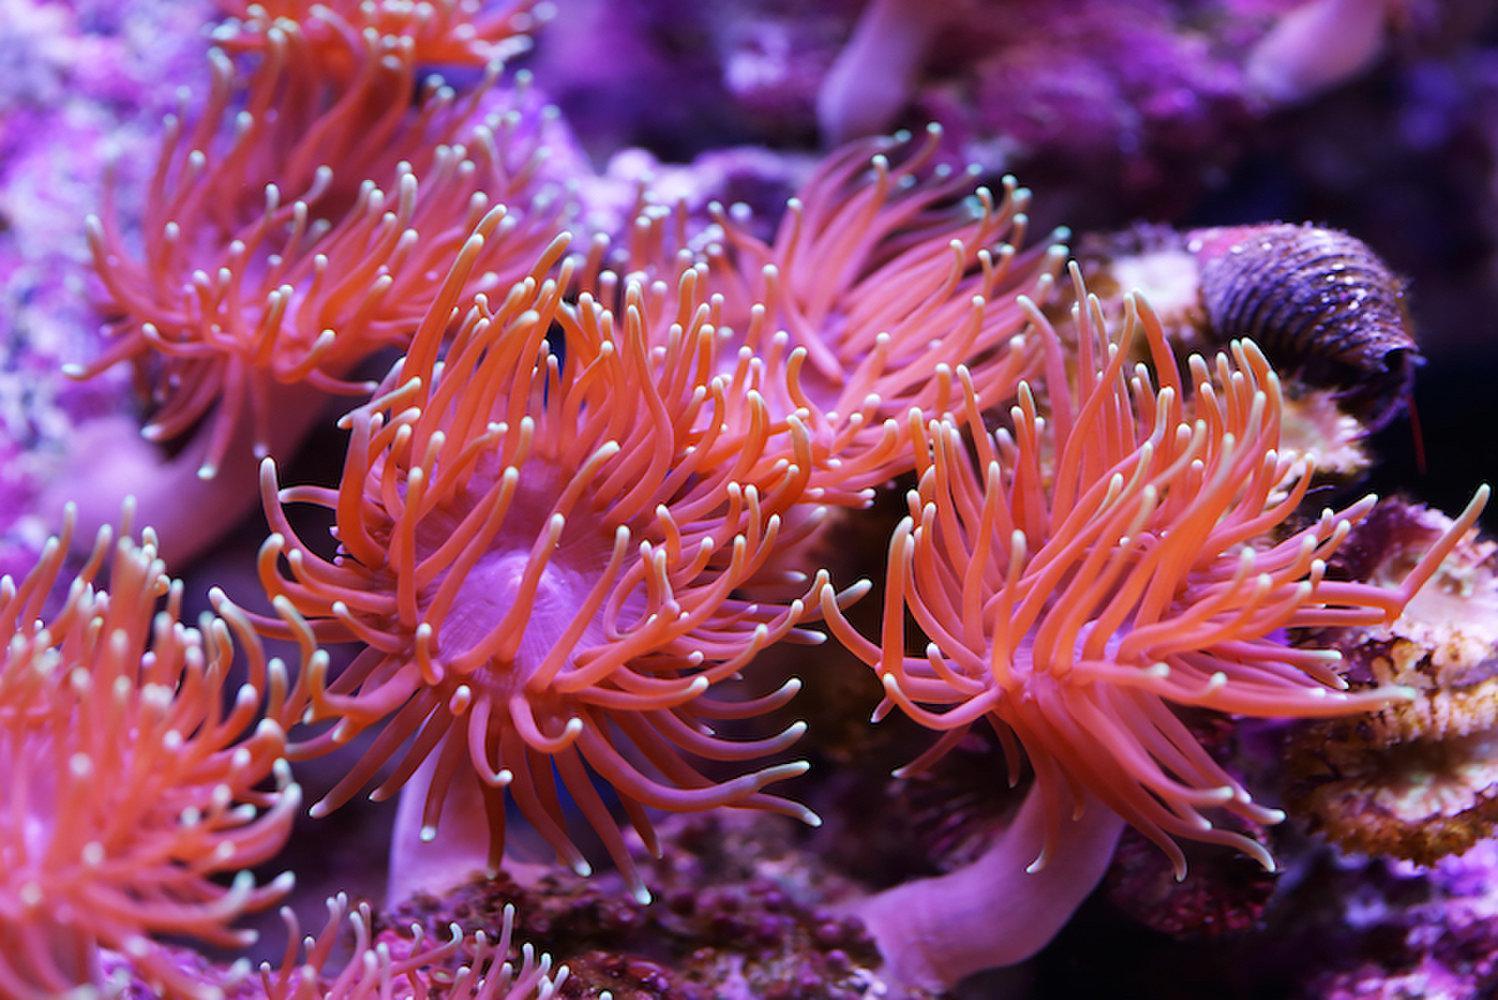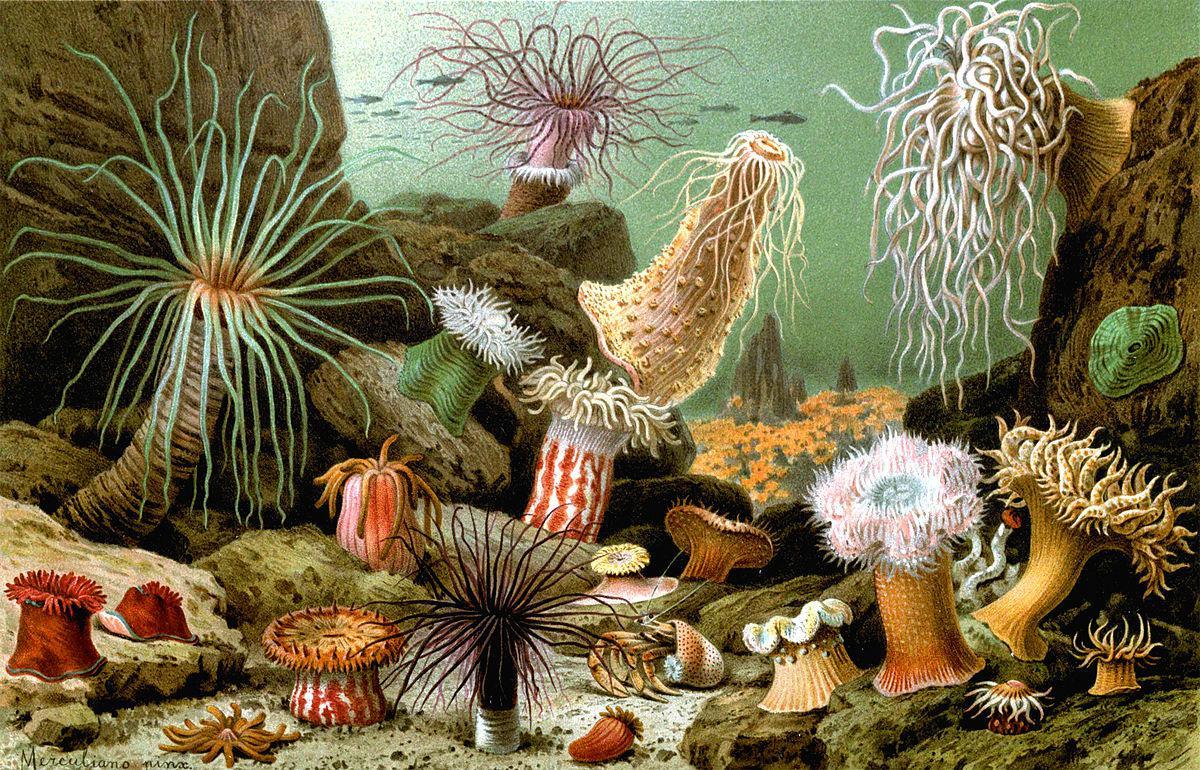The first image is the image on the left, the second image is the image on the right. For the images displayed, is the sentence "One image feature a clown fish next to a sea anemone" factually correct? Answer yes or no. No. The first image is the image on the left, the second image is the image on the right. Assess this claim about the two images: "In at least one image there is a single orange and white cloud fish swimming above a single coral.". Correct or not? Answer yes or no. No. 